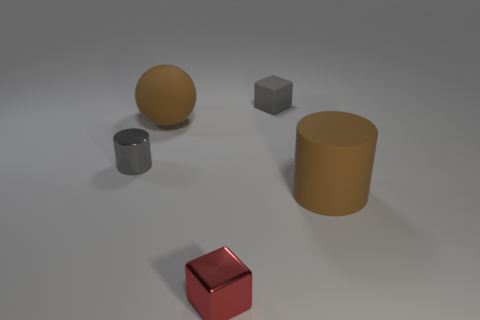Add 5 brown rubber cylinders. How many objects exist? 10 Subtract all cubes. How many objects are left? 3 Subtract 1 brown cylinders. How many objects are left? 4 Subtract all tiny objects. Subtract all gray cylinders. How many objects are left? 1 Add 4 gray matte blocks. How many gray matte blocks are left? 5 Add 5 brown rubber balls. How many brown rubber balls exist? 6 